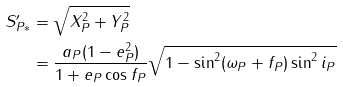Convert formula to latex. <formula><loc_0><loc_0><loc_500><loc_500>S _ { P * } ^ { \prime } & = \sqrt { X _ { P } ^ { 2 } + Y _ { P } ^ { 2 } } \\ \quad & = \frac { a _ { P } ( 1 - e _ { P } ^ { 2 } ) } { 1 + e _ { P } \cos f _ { P } } \sqrt { 1 - \sin ^ { 2 } ( \omega _ { P } + f _ { P } ) \sin ^ { 2 } i _ { P } }</formula> 